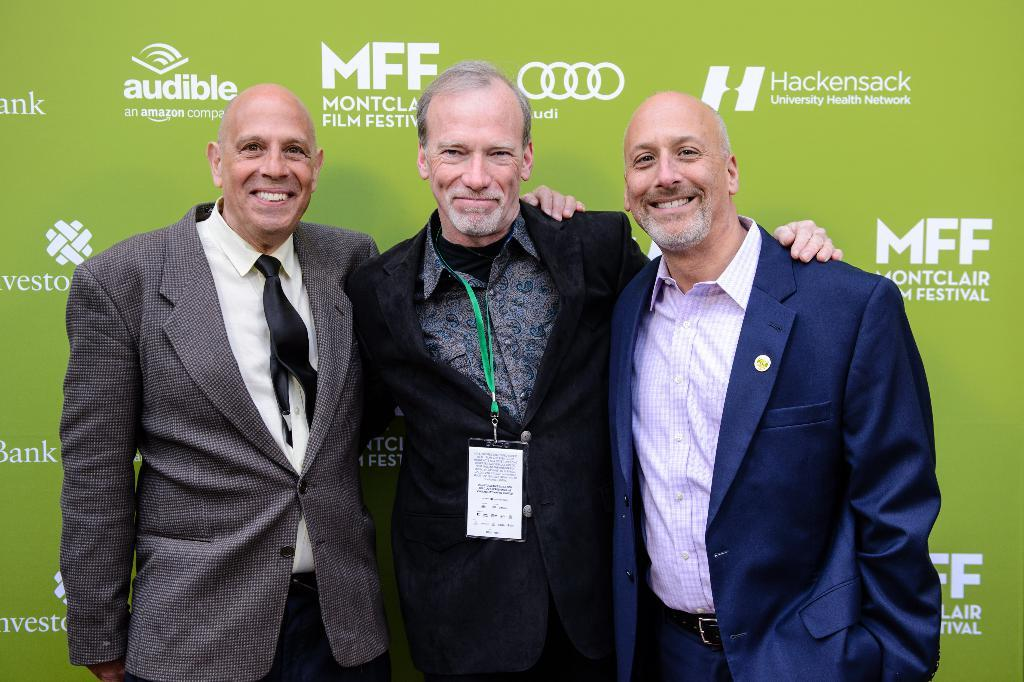How many people are in the image? There are three men in the image. What are the men doing in the image? The men are standing in the image. What expressions do the men have in the image? The men are smiling in the image. What can be seen in the background of the image? There is a hoarding visible in the background of the image. What type of cast can be seen on the cat in the image? There is no cat present in the image, and therefore no cast can be seen. 